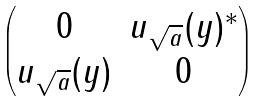<formula> <loc_0><loc_0><loc_500><loc_500>\begin{pmatrix} 0 & u _ { \sqrt { a } } ( y ) ^ { * } \\ u _ { \sqrt { a } } ( y ) & 0 \end{pmatrix}</formula> 